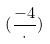Convert formula to latex. <formula><loc_0><loc_0><loc_500><loc_500>( \frac { - 4 } { \cdot } )</formula> 